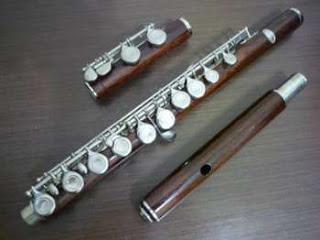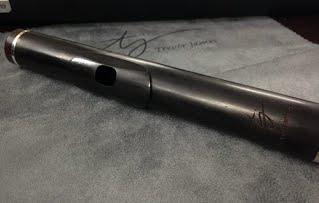The first image is the image on the left, the second image is the image on the right. For the images displayed, is the sentence "One image contains at least three flute pieces displayed in a diagonal, non-touching row, and the other image features one diagonal tube shape with a single hole on its surface." factually correct? Answer yes or no. Yes. The first image is the image on the left, the second image is the image on the right. For the images displayed, is the sentence "In one of the images, there are 3 sections of flute laying parallel to each other." factually correct? Answer yes or no. Yes. 